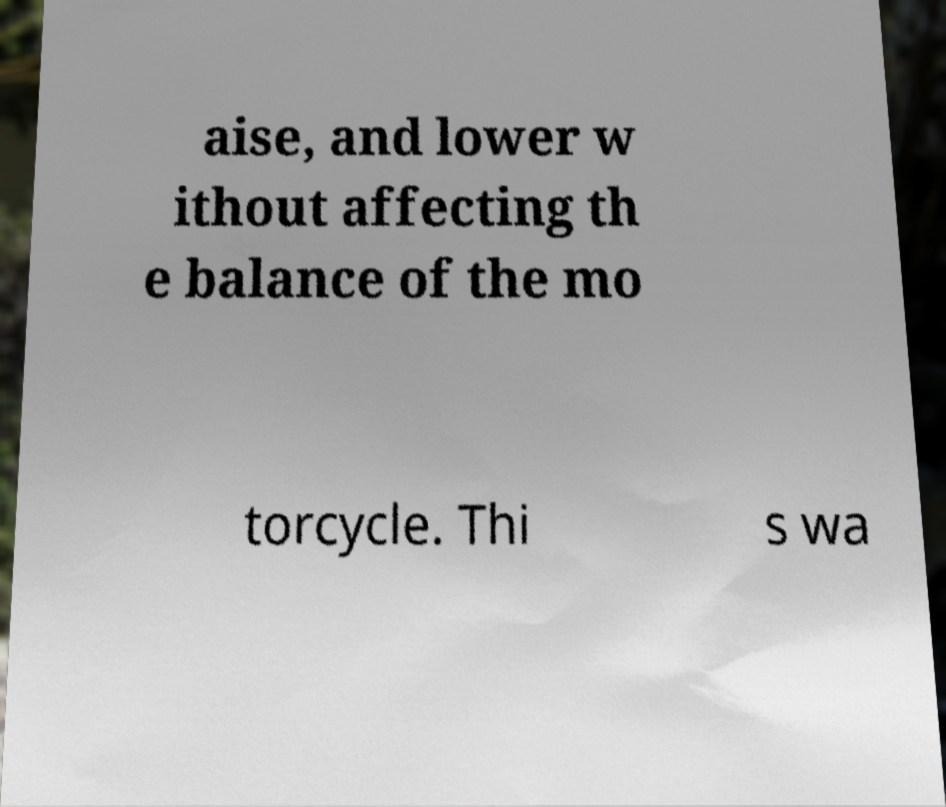Could you assist in decoding the text presented in this image and type it out clearly? aise, and lower w ithout affecting th e balance of the mo torcycle. Thi s wa 